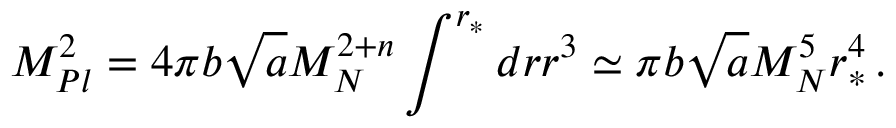Convert formula to latex. <formula><loc_0><loc_0><loc_500><loc_500>M _ { P l } ^ { 2 } = 4 \pi b \sqrt { a } M _ { N } ^ { 2 + n } \int ^ { r _ { * } } d r r ^ { 3 } \simeq \pi b \sqrt { a } M _ { N } ^ { 5 } r _ { * } ^ { 4 } \, .</formula> 